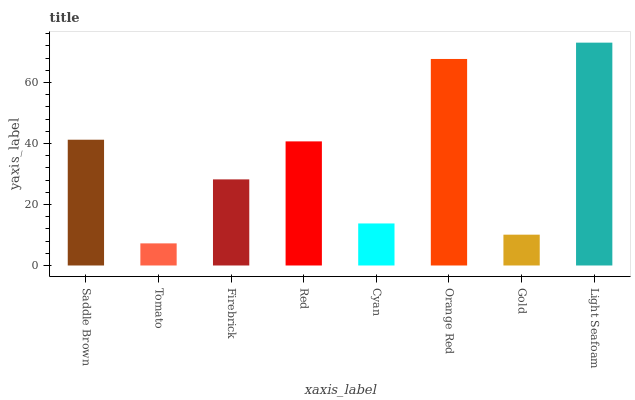Is Tomato the minimum?
Answer yes or no. Yes. Is Light Seafoam the maximum?
Answer yes or no. Yes. Is Firebrick the minimum?
Answer yes or no. No. Is Firebrick the maximum?
Answer yes or no. No. Is Firebrick greater than Tomato?
Answer yes or no. Yes. Is Tomato less than Firebrick?
Answer yes or no. Yes. Is Tomato greater than Firebrick?
Answer yes or no. No. Is Firebrick less than Tomato?
Answer yes or no. No. Is Red the high median?
Answer yes or no. Yes. Is Firebrick the low median?
Answer yes or no. Yes. Is Saddle Brown the high median?
Answer yes or no. No. Is Tomato the low median?
Answer yes or no. No. 